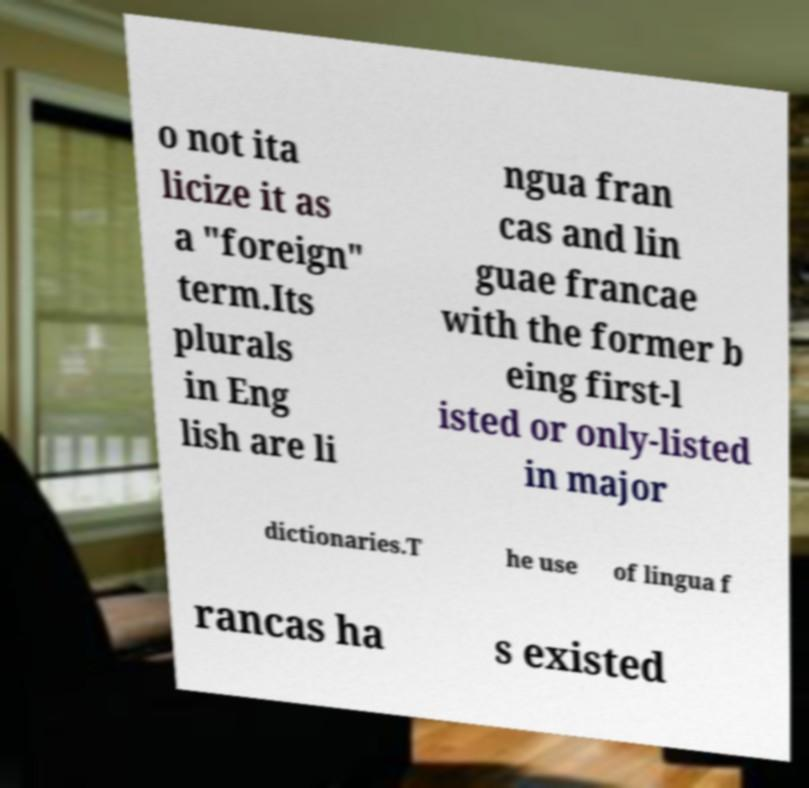Could you extract and type out the text from this image? o not ita licize it as a "foreign" term.Its plurals in Eng lish are li ngua fran cas and lin guae francae with the former b eing first-l isted or only-listed in major dictionaries.T he use of lingua f rancas ha s existed 